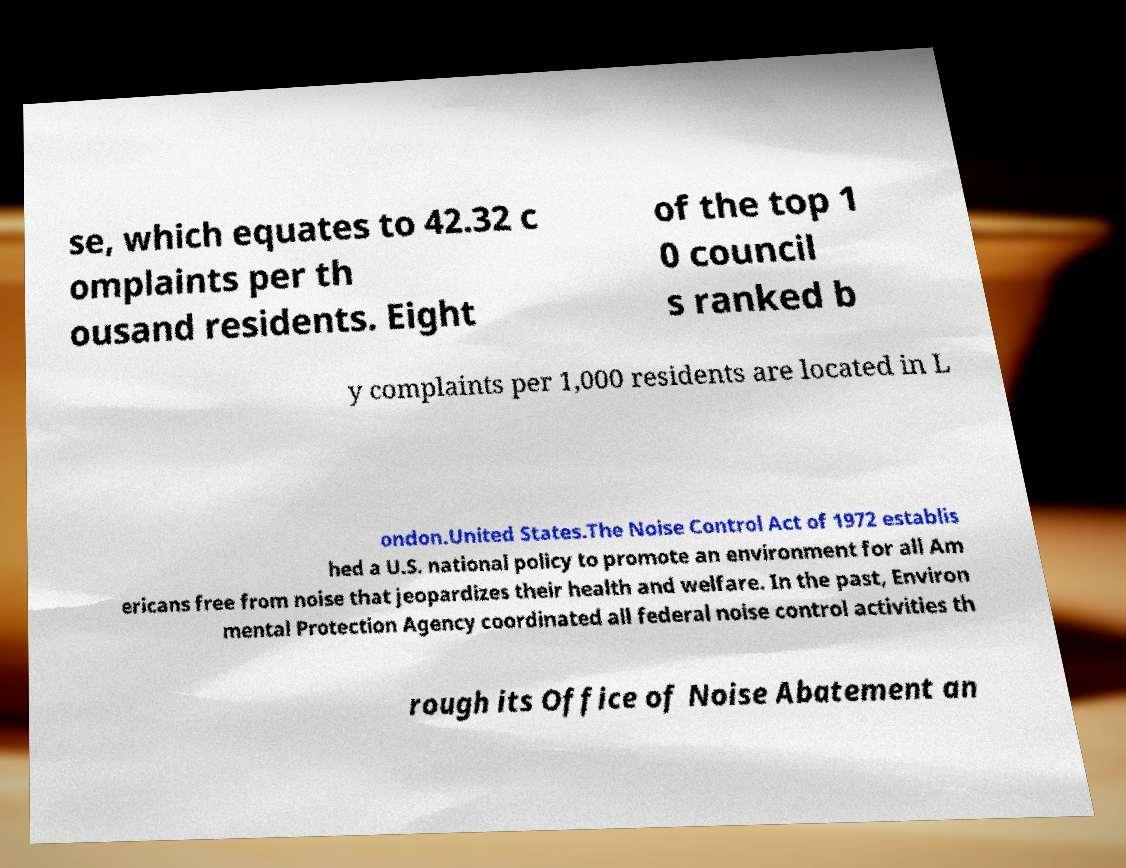There's text embedded in this image that I need extracted. Can you transcribe it verbatim? se, which equates to 42.32 c omplaints per th ousand residents. Eight of the top 1 0 council s ranked b y complaints per 1,000 residents are located in L ondon.United States.The Noise Control Act of 1972 establis hed a U.S. national policy to promote an environment for all Am ericans free from noise that jeopardizes their health and welfare. In the past, Environ mental Protection Agency coordinated all federal noise control activities th rough its Office of Noise Abatement an 